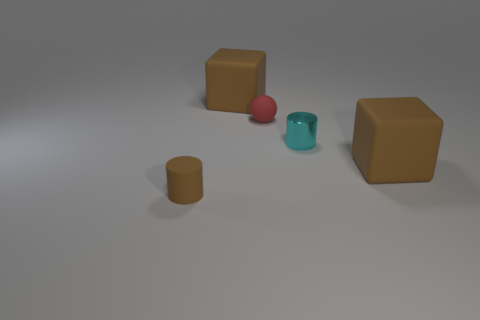There is a big rubber object on the right side of the sphere; does it have the same color as the rubber cylinder?
Your response must be concise. Yes. Are there any large rubber cubes of the same color as the small matte cylinder?
Provide a succinct answer. Yes. Are there fewer brown cylinders than large green rubber cylinders?
Offer a terse response. No. How many cylinders have the same size as the cyan metallic object?
Make the answer very short. 1. What is the cyan cylinder made of?
Offer a terse response. Metal. What is the size of the object behind the small matte ball?
Your answer should be compact. Large. What number of tiny brown things are the same shape as the tiny cyan object?
Your answer should be compact. 1. The small object that is the same material as the brown cylinder is what shape?
Offer a very short reply. Sphere. How many red objects are rubber things or metallic cylinders?
Your answer should be compact. 1. Are there any small matte cylinders to the right of the red matte sphere?
Give a very brief answer. No. 